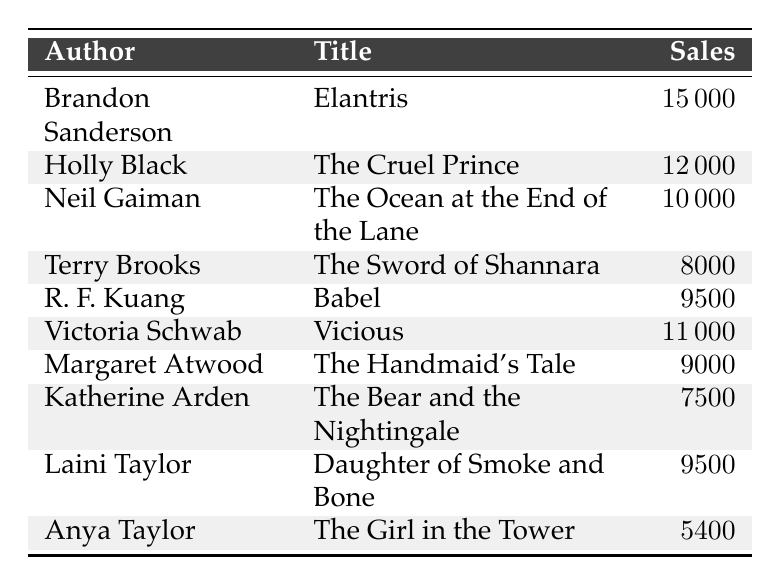What is the title of the book with the highest sales? The table shows the sales units for each title. The highest sales is 15,000 units for "Elantris" by Brandon Sanderson.
Answer: Elantris How many sales units did Victoria Schwab's book have? Referring to the table, Victoria Schwab's book "Vicious" has 11,000 sales units.
Answer: 11000 Which author has the least sales units listed? Anya Taylor's book "The Girl in the Tower" has the lowest sales with 5,400 units.
Answer: Anya Taylor What is the total number of sales units for the top three books? Add the sales units of the top three books: 15,000 (Elantris) + 12,000 (The Cruel Prince) + 11,000 (Vicious) = 38,000 units.
Answer: 38000 Is "The Handmaid's Tale" categorized as Dark Fantasy? The table categorizes "The Handmaid's Tale" under Dystopian Dark Fantasy, which means it is not exclusively Dark Fantasy.
Answer: No What is the average sales units for the dark fantasy novels listed? Sum the sales units: 15,000 + 12,000 + 10,000 + 11,000 + 9,000 + 7,500 + 9,500 + 5,400 = 84,400 units. There are 8 books, so average = 84,400 / 8 = 10,550 units.
Answer: 10550 How many authors have sales above 9,000 units? Counting the authors with sales above 9,000: Brandon Sanderson, Holly Black, Neil Gaiman, Victoria Schwab, R. F. Kuang, and Margaret Atwood gives us a total of 6 authors.
Answer: 6 Which book has sales units closest to 10,000? Comparing the sales units, "Vicious" with 11,000 is closest to 10,000, and "The Ocean at the End of the Lane" has exactly 10,000 units. The closest is a tie; they are both near 10,000 units.
Answer: The Ocean at the End of the Lane and Vicious What genre has the most books listed with sales? The table shows that Dark Fantasy encompasses most entries. Counting the entries: several books fall under this genre compared to others, verifying it has the most listed.
Answer: Dark Fantasy What are the total sales units for Epic Dark Fantasy? The only book listed as Epic Dark Fantasy is "The Sword of Shannara," with 8,000 sales units. This is the total.
Answer: 8000 